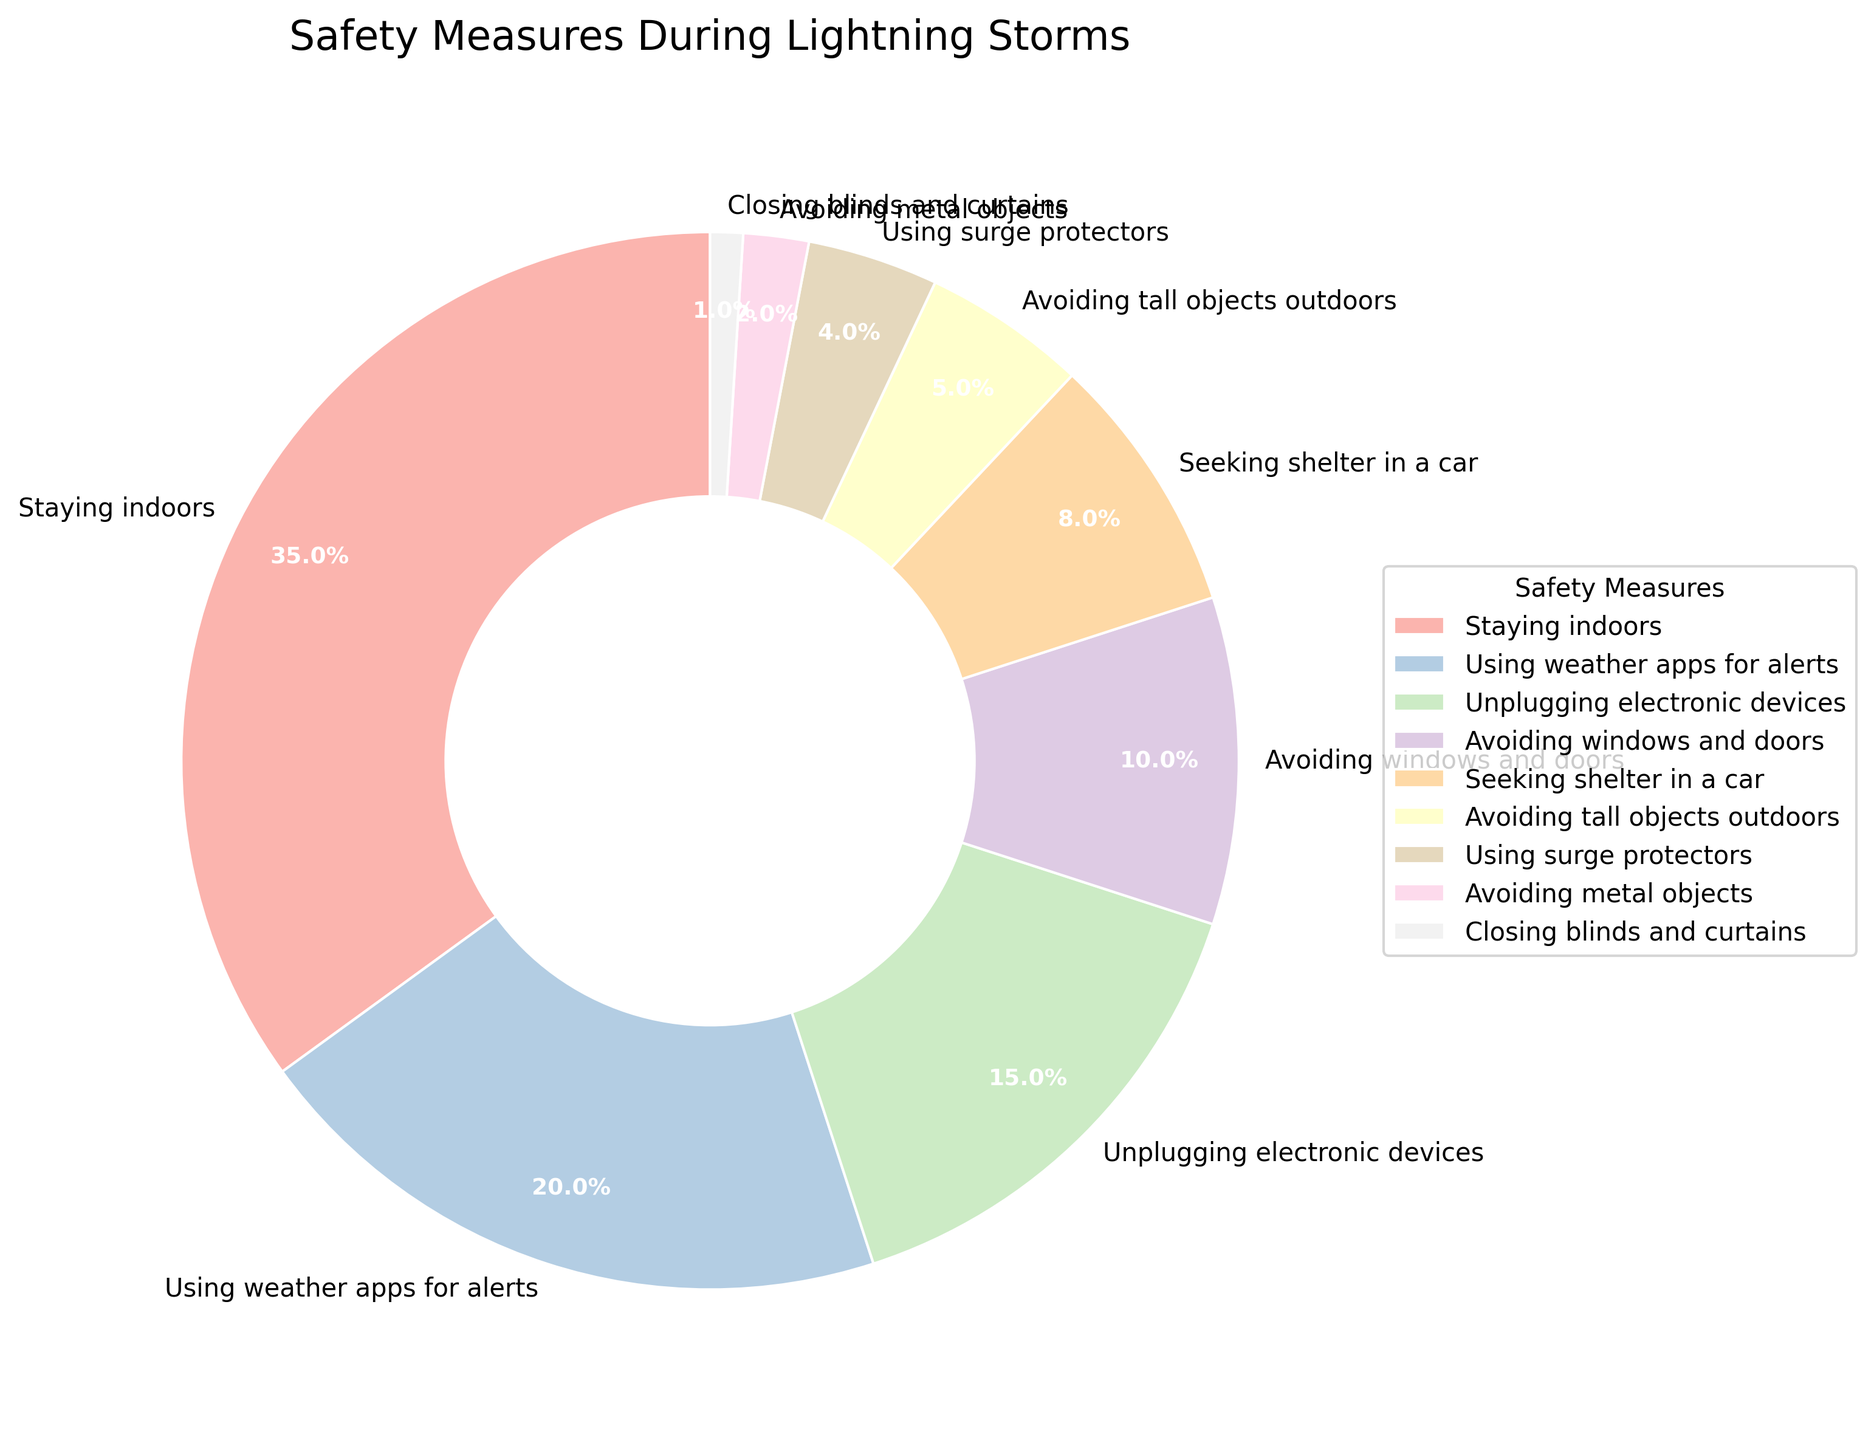What safety measure is most commonly taken during lightning storms? The largest slice of the pie chart represents the safety measure that is most commonly taken. The slice labeled "Staying indoors" is the largest at 35%.
Answer: Staying indoors What proportion of people use weather apps for alerts compared to those staying indoors? The slice for "Using weather apps for alerts" is 20% while "Staying indoors" is 35%. To compare the proportions, we look at the percentages directly.
Answer: 20% vs 35% Which safety measure has the smallest proportion, and what is its percentage? The smallest slice of the pie chart represents the least common safety measure. The slice labeled "Closing blinds and curtains" is the smallest at 1%.
Answer: Closing blinds and curtains, 1% What is the combined percentage of people who take measures that involve avoiding metal objects and using surge protectors? We need to add the percentages of the slices labeled "Avoiding metal objects" (2%) and "Using surge protectors" (4%). So, 2% + 4% = 6%.
Answer: 6% How much more common is avoiding windows and doors than seeking shelter in a car? The percentage for "Avoiding windows and doors" is 10% and for "Seeking shelter in a car" is 8%. The difference is 10% - 8% = 2%.
Answer: 2% Which safety measures make up a majority (more than 50%) of the overall actions taken? We need to sum the percentages from the largest slices until the sum exceeds 50%. "Staying indoors" (35%) and "Using weather apps for alerts" (20%) sum up to 55%, which is more than 50%.
Answer: Staying indoors, Using weather apps for alerts What is the difference in percentage between people avoiding tall objects outdoors and those avoiding metal objects? The percentages for "Avoiding tall objects outdoors" and "Avoiding metal objects" are 5% and 2%, respectively. The difference is 5% - 2% = 3%.
Answer: 3% Which two safety measures together have a higher percentage than staying indoors alone? We need to find a combination of two slices that together sum to more than 35%. "Using weather apps for alerts" (20%) and "Unplugging electronic devices" (15%) together total 35% exactly, which isn't more. Combining any higher percentage slice with "Avoiding windows and doors" (10%) and others like (8%, 15%) or (5%) easily surpasses 35%.
Answer: Several valid pairs more than 35%, e.g., Using weather apps + Unplugging electronic devices 